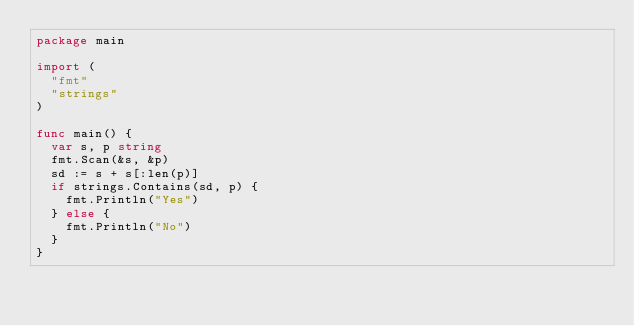Convert code to text. <code><loc_0><loc_0><loc_500><loc_500><_Go_>package main

import (
	"fmt"
	"strings"
)

func main() {
	var s, p string
	fmt.Scan(&s, &p)
	sd := s + s[:len(p)]
	if strings.Contains(sd, p) {
		fmt.Println("Yes")
	} else {
		fmt.Println("No")
	}
}

</code> 